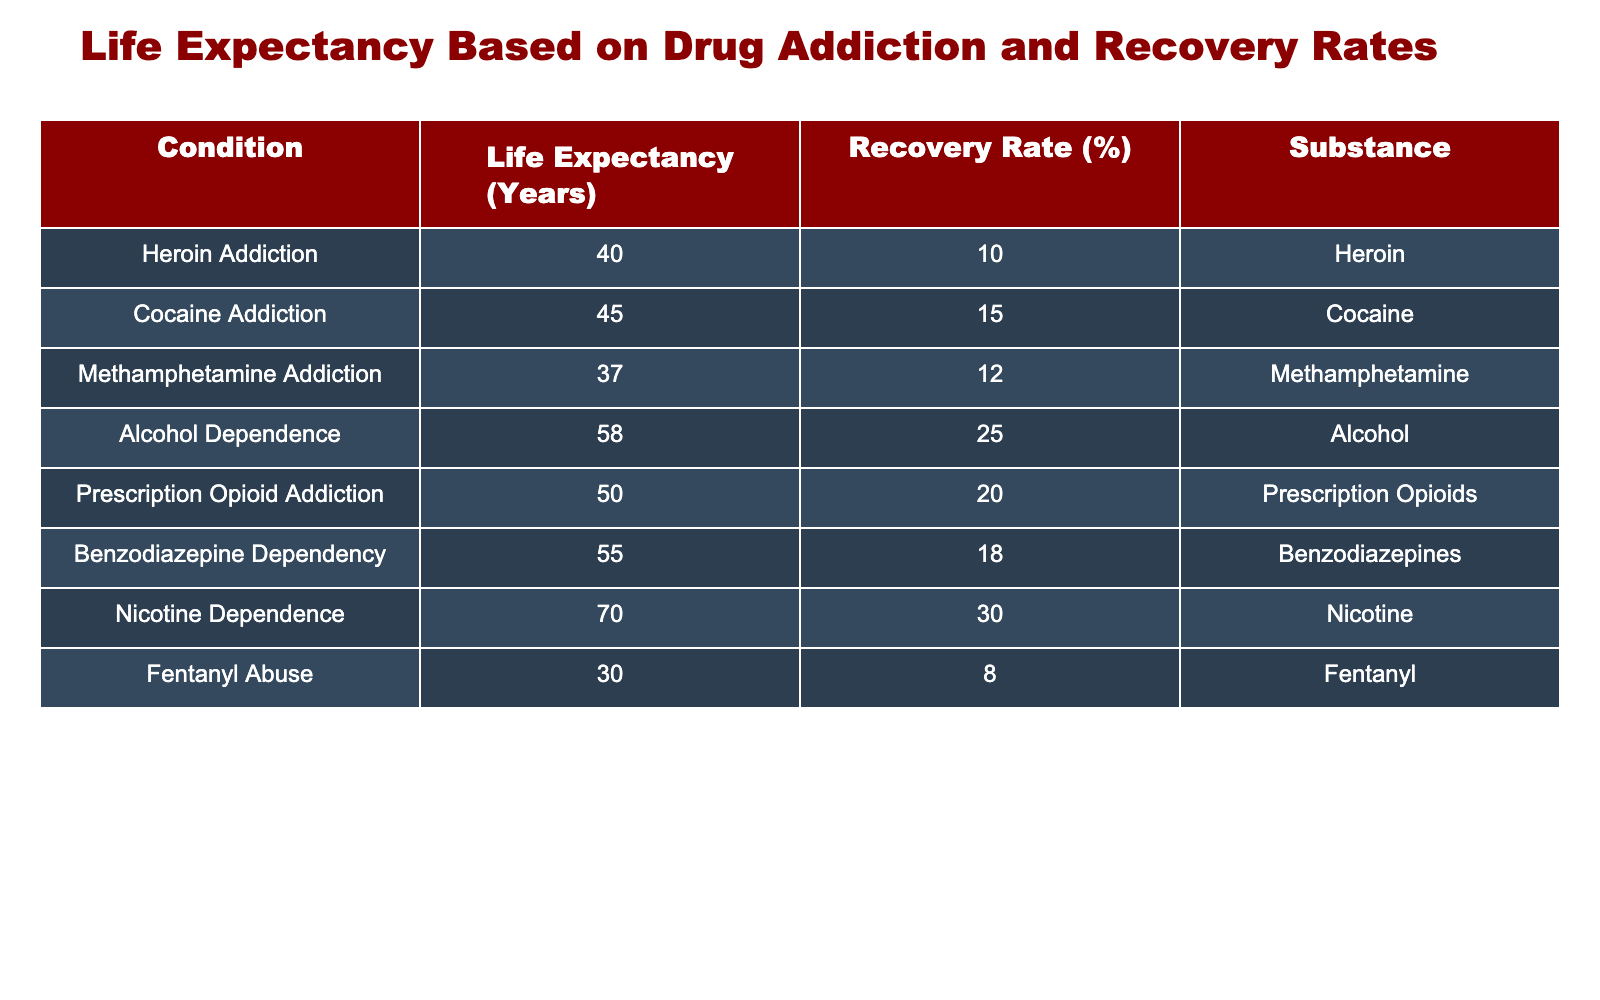What is the life expectancy for someone with Alcohol Dependence? According to the table, the life expectancy for someone with Alcohol Dependence is listed directly in the "Life Expectancy (Years)" column. It shows a value of 58 years.
Answer: 58 years What is the recovery rate for Methamphetamine Addiction? The recovery rate for Methamphetamine Addiction can be found in the "Recovery Rate (%)" column, where it is explicitly mentioned as 12%.
Answer: 12% Which addiction has the lowest life expectancy? By examining the "Life Expectancy (Years)" column, I can identify that Fentanyl Abuse has the lowest value of 30 years compared to all other listed addictions.
Answer: Fentanyl Abuse What is the average life expectancy of all addictions listed? To find the average life expectancy, first, we sum the life expectancies (40 + 45 + 37 + 58 + 50 + 55 + 70 + 30 = 385), then divide by the number of addictions (8). So, 385/8 = 48.125 years.
Answer: 48.125 years Is the recovery rate for Nicotine Dependence greater than that for Heroin Addiction? Looking at the "Recovery Rate (%)" column, Nicotine Dependence has a recovery rate of 30%, while Heroin Addiction has a recovery rate of 10%. Since 30 > 10, the statement is true.
Answer: Yes What substance has the highest recovery rate and what is that rate? By reviewing the "Recovery Rate (%)" column, I find that Nicotine Dependence has the highest recovery rate at 30%, which is more than all other substances listed.
Answer: Nicotine Dependence, 30% If you combined the recovery rates of Alcohol Dependence and Prescription Opioid Addiction, what would that total be? The recovery rate for Alcohol Dependence is 25% and for Prescription Opioid Addiction is 20%. Adding those together (25 + 20) gives a total recovery rate of 45%.
Answer: 45% How many substances listed have a life expectancy less than 50 years? Looking at the life expectancy values, I can count that Heroin Addiction (40), Methamphetamine Addiction (37), Fentanyl Abuse (30) total 3 substances that have a life expectancy of less than 50 years.
Answer: 3 What is the difference in life expectancy between Benzodiazepine Dependency and Cocaine Addiction? The life expectancy for Benzodiazepine Dependency is 55 years, while for Cocaine Addiction it is 45 years. The difference is calculated by subtracting (55 - 45 = 10 years).
Answer: 10 years 